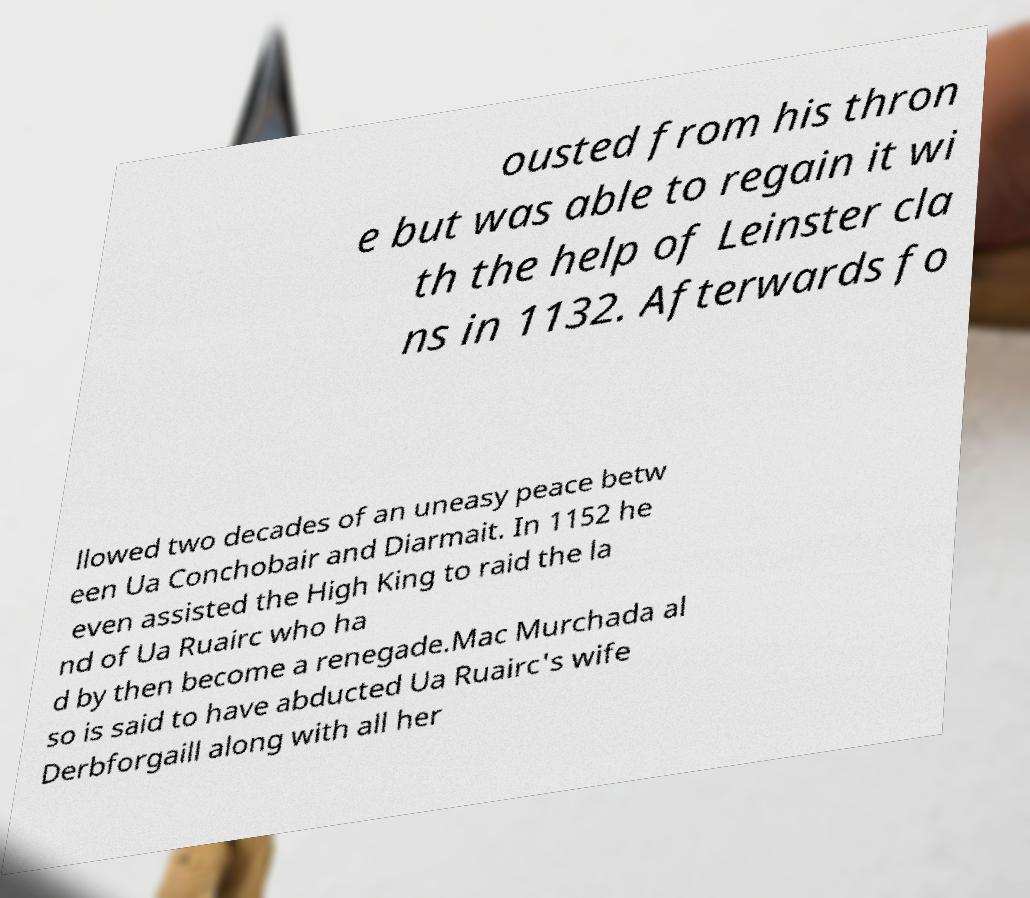I need the written content from this picture converted into text. Can you do that? ousted from his thron e but was able to regain it wi th the help of Leinster cla ns in 1132. Afterwards fo llowed two decades of an uneasy peace betw een Ua Conchobair and Diarmait. In 1152 he even assisted the High King to raid the la nd of Ua Ruairc who ha d by then become a renegade.Mac Murchada al so is said to have abducted Ua Ruairc's wife Derbforgaill along with all her 